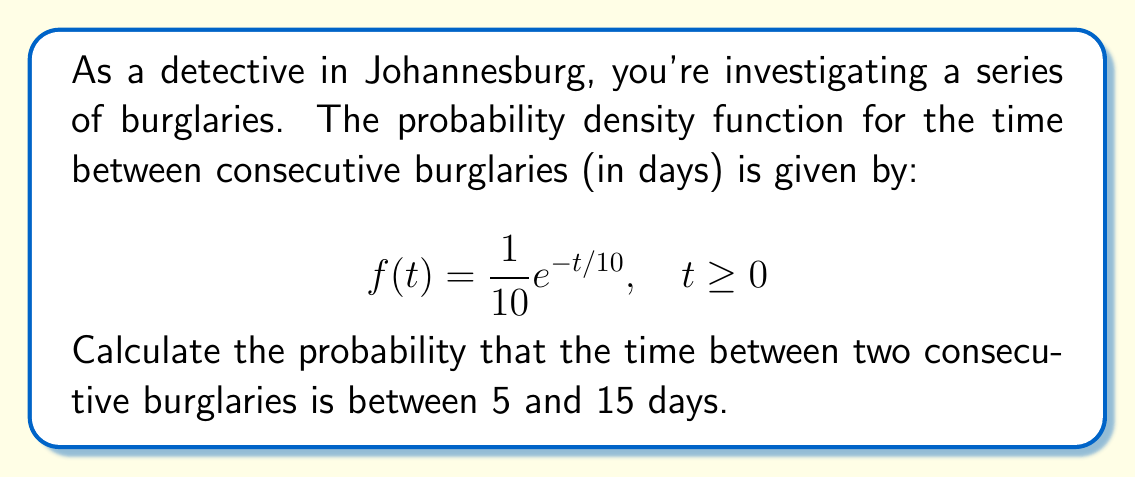Provide a solution to this math problem. To solve this problem, we need to integrate the probability density function over the given interval. Here's the step-by-step solution:

1) The probability is given by the integral of f(t) from 5 to 15:

   $$P(5 \leq T \leq 15) = \int_5^{15} f(t) dt = \int_5^{15} \frac{1}{10}e^{-t/10} dt$$

2) To solve this integral, we can use the substitution method:
   Let $u = -t/10$, then $du = -\frac{1}{10}dt$ or $dt = -10du$

3) When $t = 5$, $u = -0.5$
   When $t = 15$, $u = -1.5$

4) Substituting:

   $$\int_5^{15} \frac{1}{10}e^{-t/10} dt = -\int_{-0.5}^{-1.5} e^u du$$

5) Evaluate the integral:

   $$-\int_{-0.5}^{-1.5} e^u du = -[e^u]_{-0.5}^{-1.5} = -(e^{-1.5} - e^{-0.5})$$

6) Calculate the final result:

   $$-(e^{-1.5} - e^{-0.5}) = e^{-0.5} - e^{-1.5} \approx 0.3180$$

Therefore, the probability that the time between two consecutive burglaries is between 5 and 15 days is approximately 0.3180 or 31.80%.
Answer: $e^{-0.5} - e^{-1.5} \approx 0.3180$ or 31.80% 